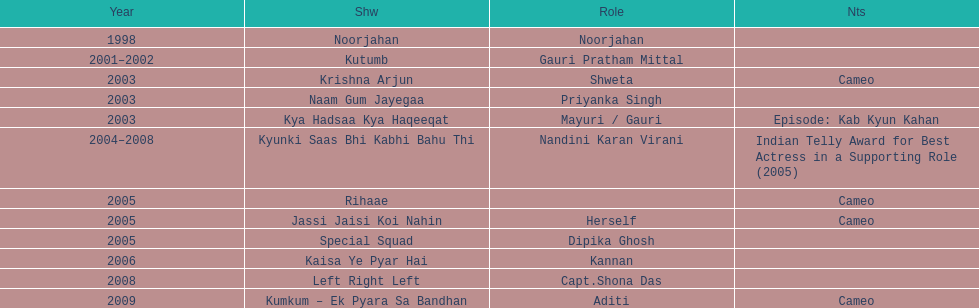For how many years did the longest-running show last? 4. 